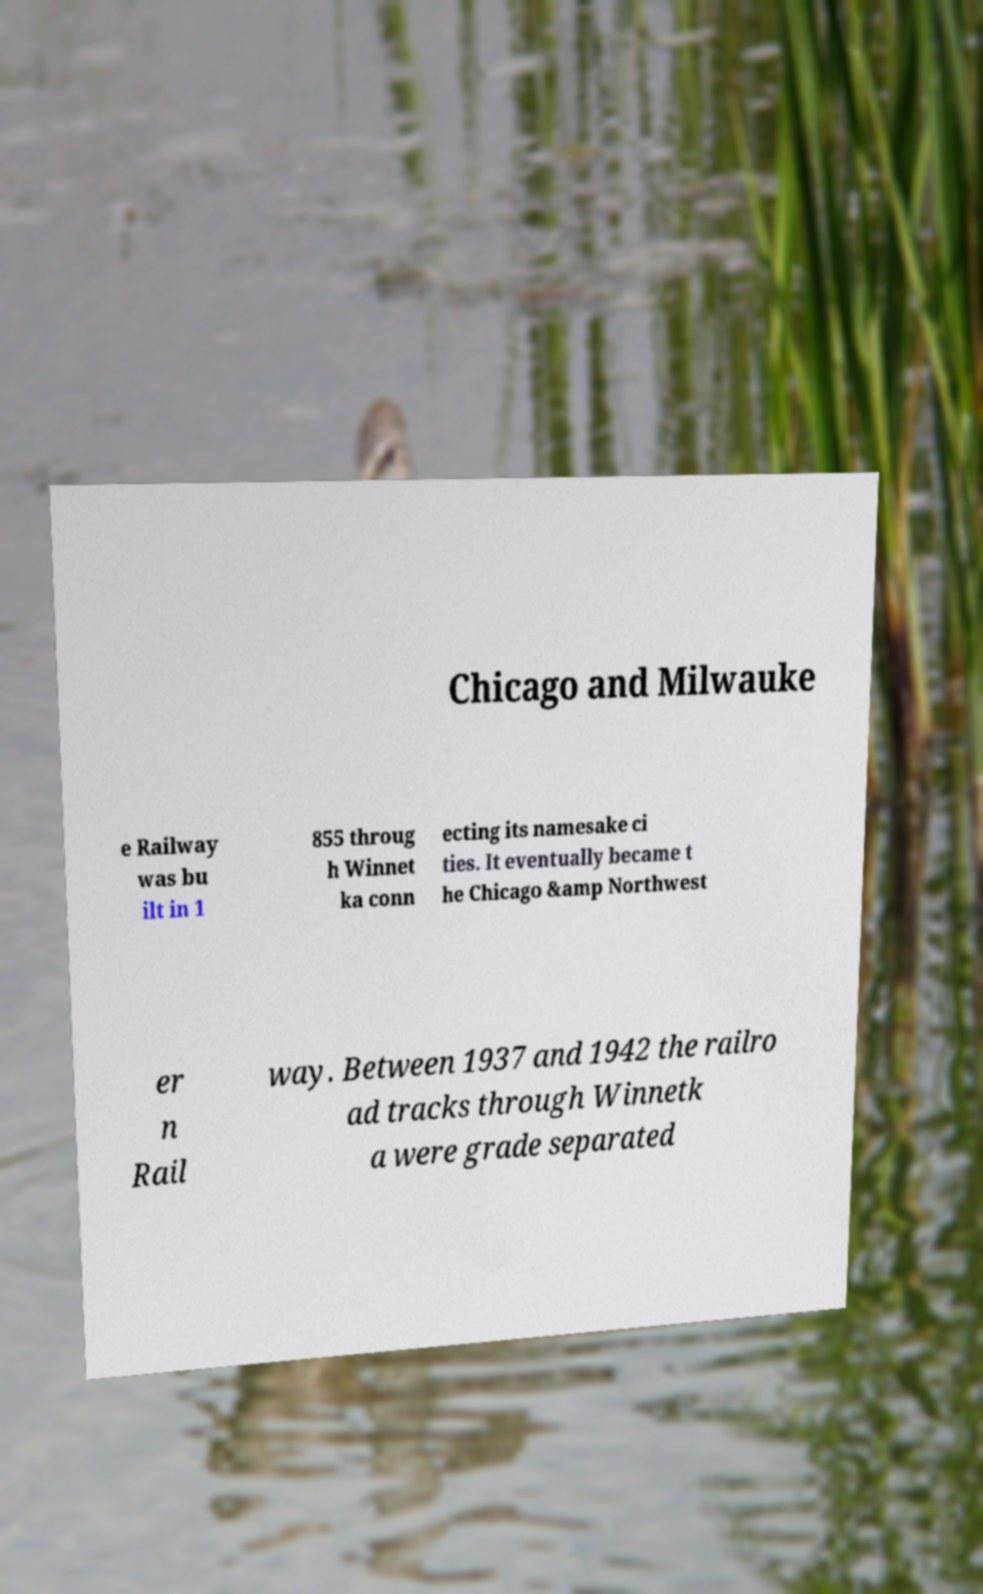Could you assist in decoding the text presented in this image and type it out clearly? Chicago and Milwauke e Railway was bu ilt in 1 855 throug h Winnet ka conn ecting its namesake ci ties. It eventually became t he Chicago &amp Northwest er n Rail way. Between 1937 and 1942 the railro ad tracks through Winnetk a were grade separated 